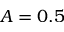<formula> <loc_0><loc_0><loc_500><loc_500>A = 0 . 5</formula> 